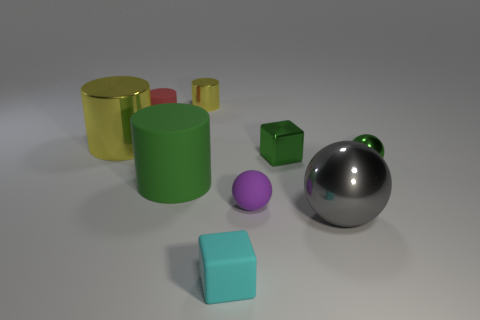Subtract all brown spheres. How many yellow cylinders are left? 2 Subtract all gray balls. How many balls are left? 2 Subtract all red cylinders. How many cylinders are left? 3 Subtract 2 cylinders. How many cylinders are left? 2 Add 1 brown metallic balls. How many objects exist? 10 Subtract all cyan cylinders. Subtract all blue balls. How many cylinders are left? 4 Add 7 tiny brown cubes. How many tiny brown cubes exist? 7 Subtract 0 cyan cylinders. How many objects are left? 9 Subtract all blocks. How many objects are left? 7 Subtract all green cubes. Subtract all big matte objects. How many objects are left? 7 